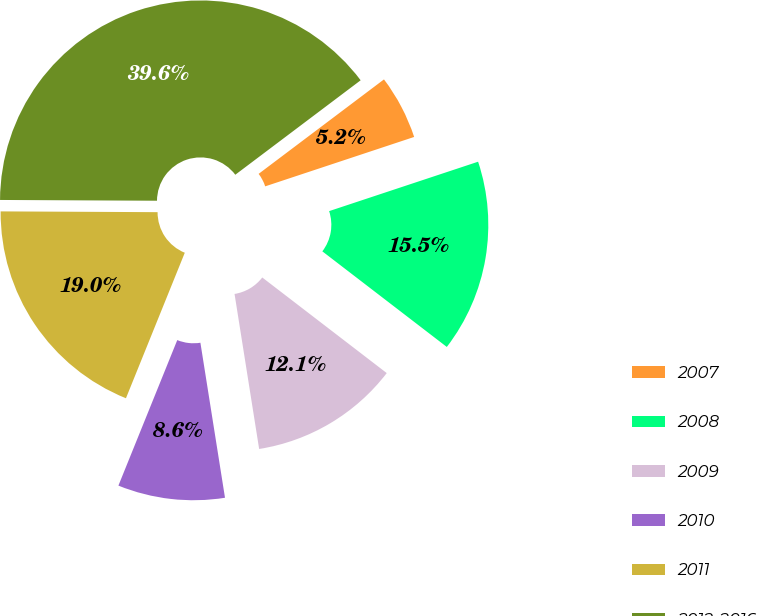Convert chart. <chart><loc_0><loc_0><loc_500><loc_500><pie_chart><fcel>2007<fcel>2008<fcel>2009<fcel>2010<fcel>2011<fcel>2012-2016<nl><fcel>5.18%<fcel>15.52%<fcel>12.07%<fcel>8.62%<fcel>18.96%<fcel>39.64%<nl></chart> 